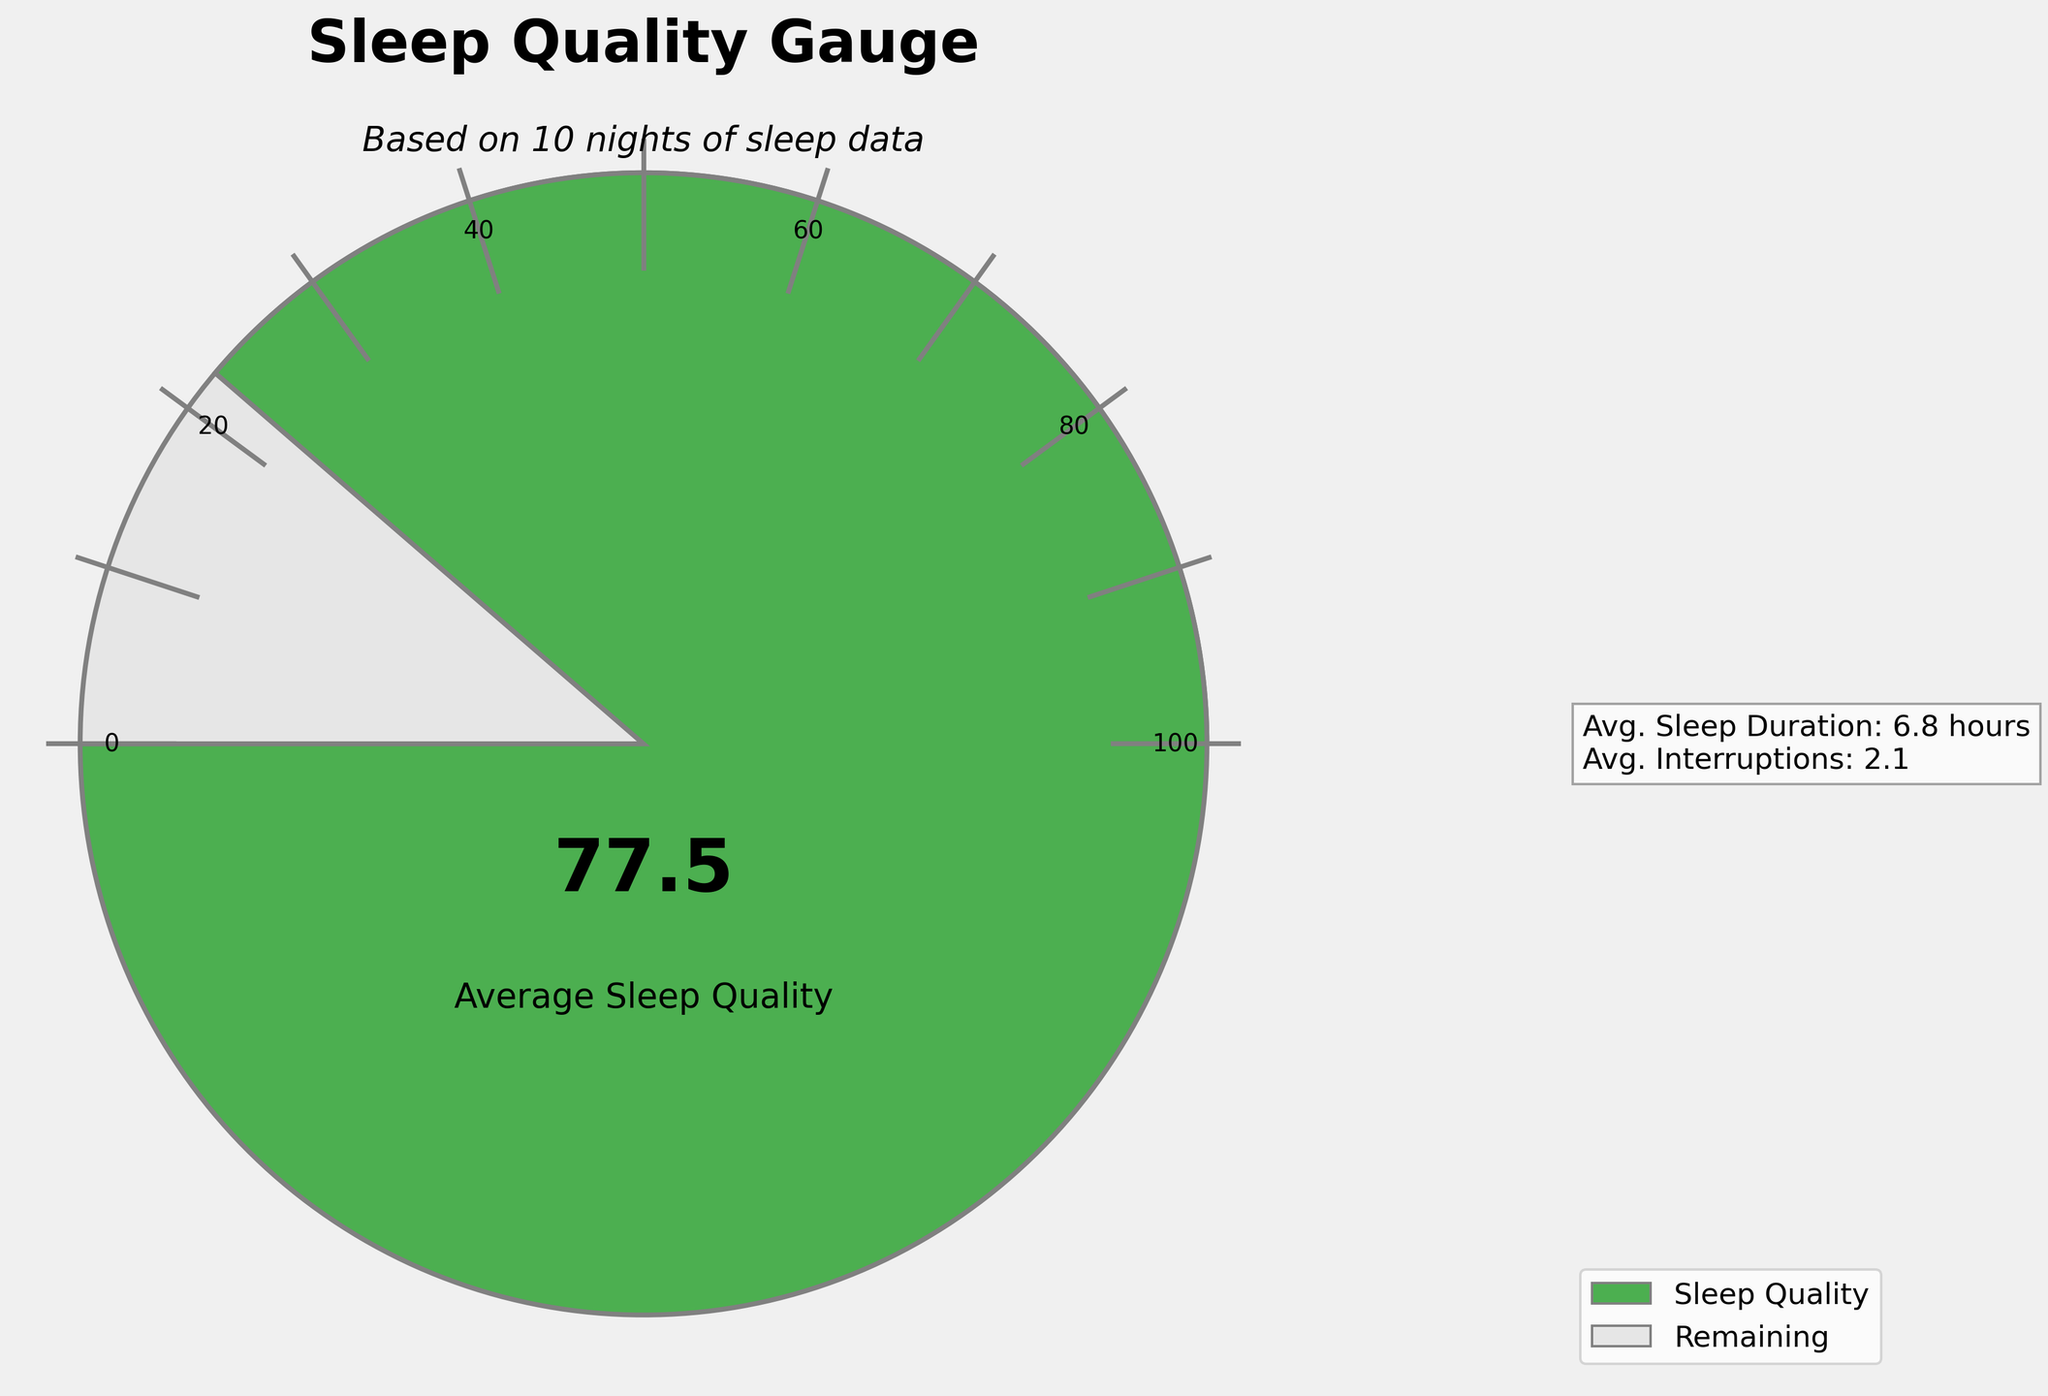How many nights of sleep data are used in the figure? The title indicates that the gauge is based on multiple nights of sleep data. The text below the title specifies the exact number of nights.
Answer: 10 What is the title of the figure? The main title is located at the top center of the figure.
Answer: Sleep Quality Gauge What is the average sleep quality score? The gauge dial shows the average sleep quality score in large numbers at the center of the gauge.
Answer: 77.5 What is the average sleep duration? The average sleep duration is provided in the additional information text to the right of the gauge.
Answer: 7.3 hours How many marks are there on the gauge dial? Marks are visible along the arc of the gauge, starting from 0 to 100, incremented by 10.
Answer: 11 marks Compare the average number of interruptions versus the average sleep duration. The figure provides both values in the additional information to the right of the gauge. Compare the values directly.
Answer: Avg. interruptions (2.1) are much less than avg. sleep duration (7.3 hours) If the average sleep quality score was lowered by 10 points, what would it be? Subtract 10 from the displayed average sleep quality score.
Answer: 67.5 Does the figure indicate any specific color for displaying sleep quality? The color used to fill the gauge up to the displayed sleep quality score is shown, usually a particular color like green.
Answer: Yes, green What would be the angle in degrees for a sleep quality score of 50? The gauge uses a semicircle (180 degrees) for scores from 0 to 100. A score of 50 would be halfway.
Answer: 180/2 = 90 degrees 